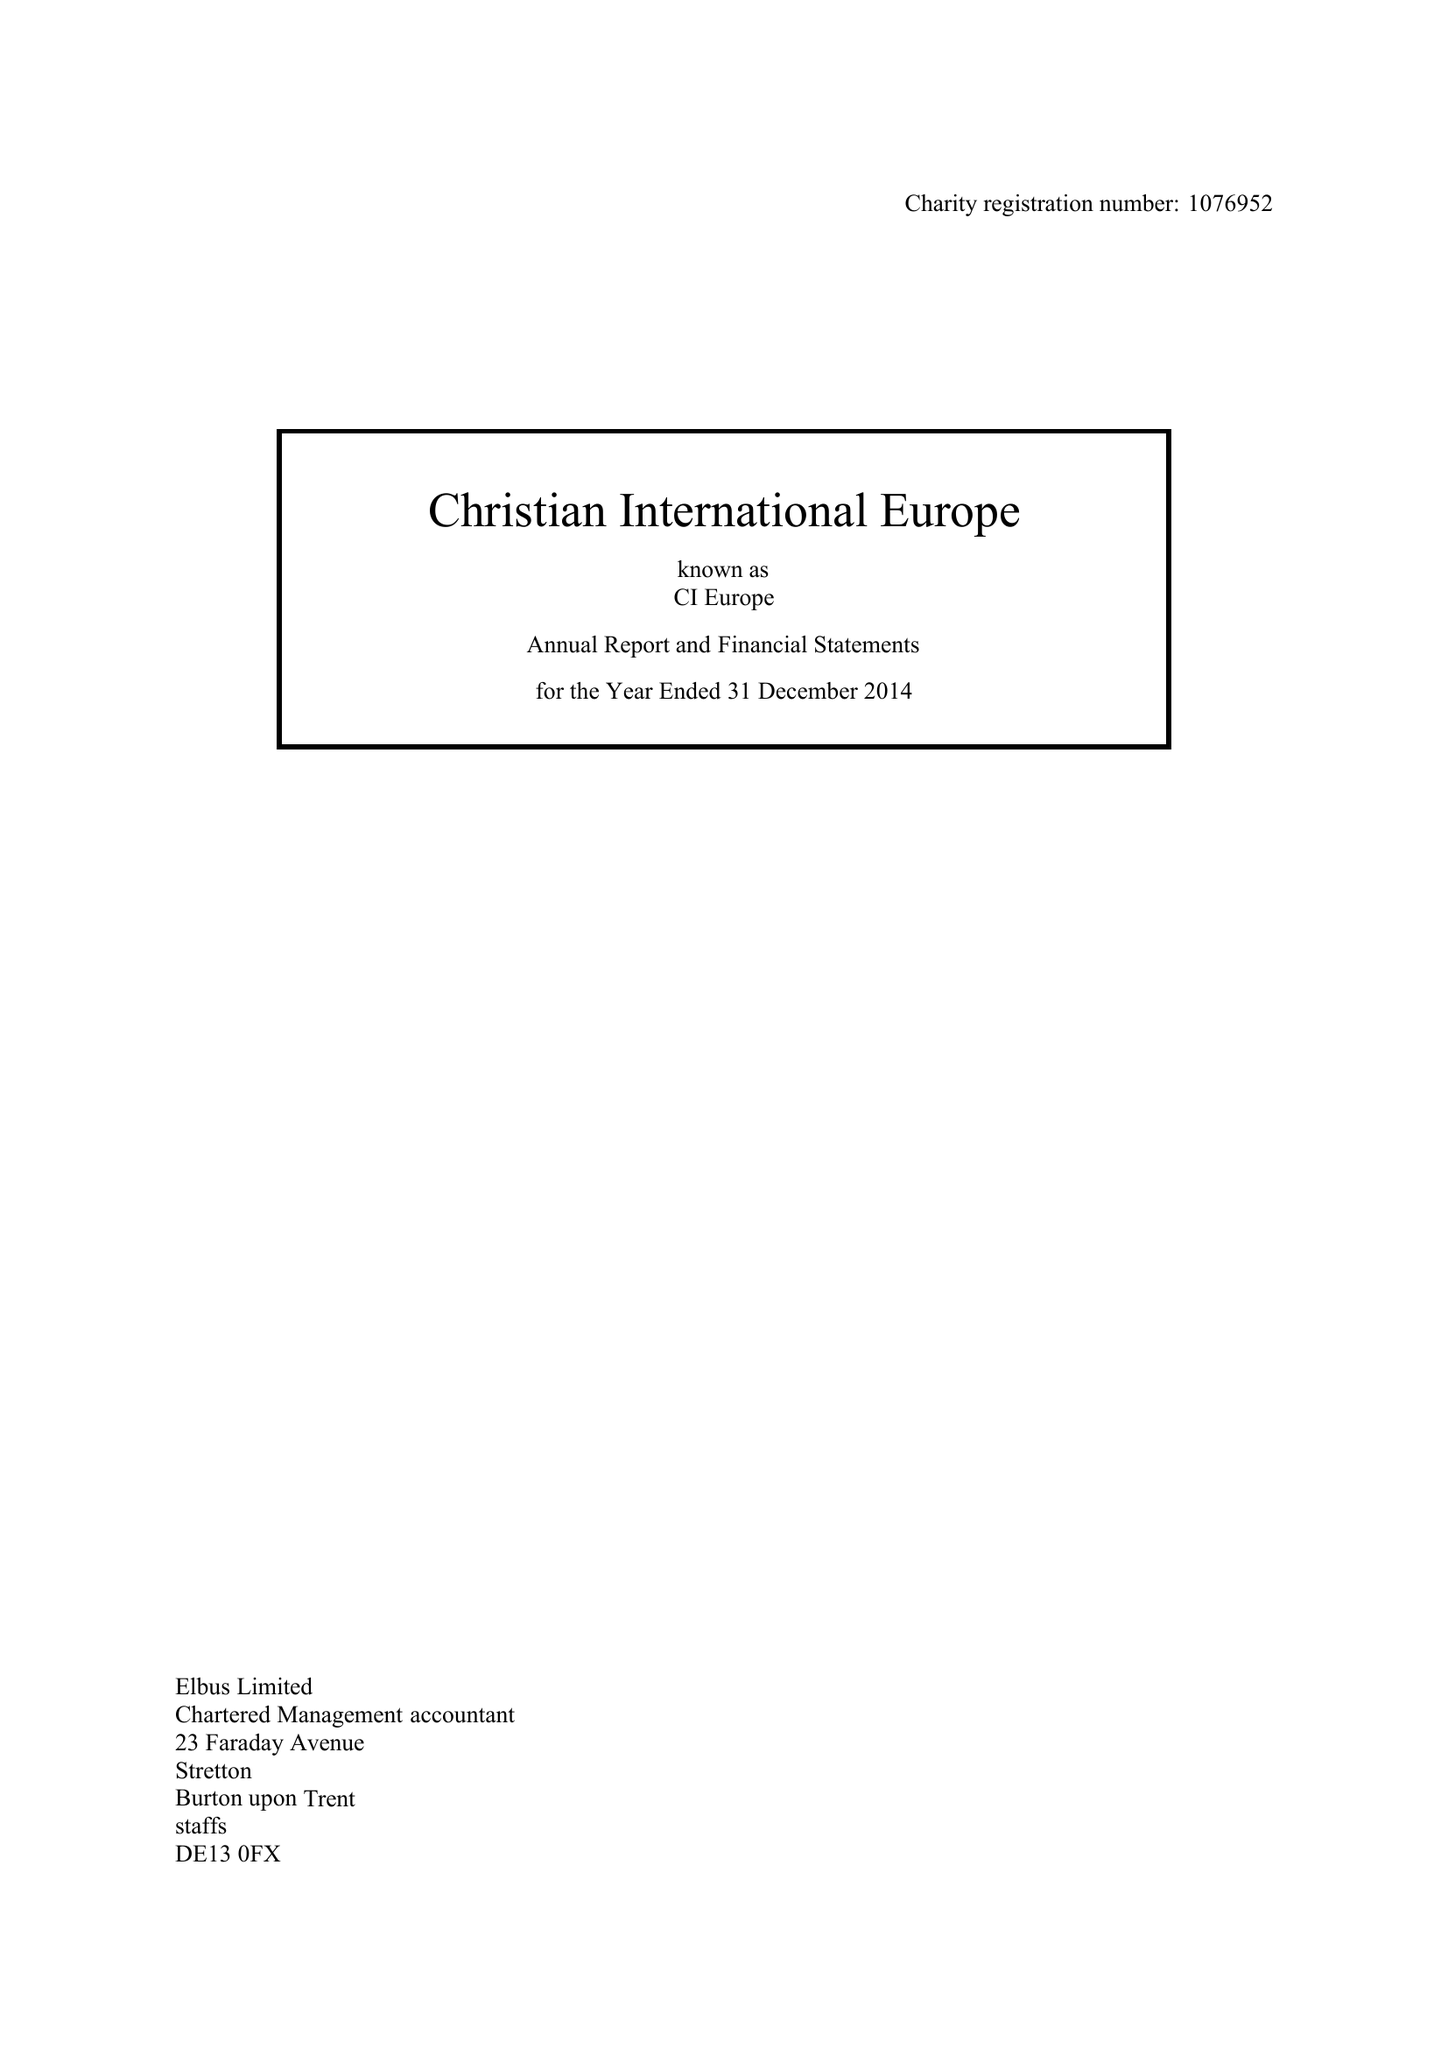What is the value for the report_date?
Answer the question using a single word or phrase. 2014-12-31 